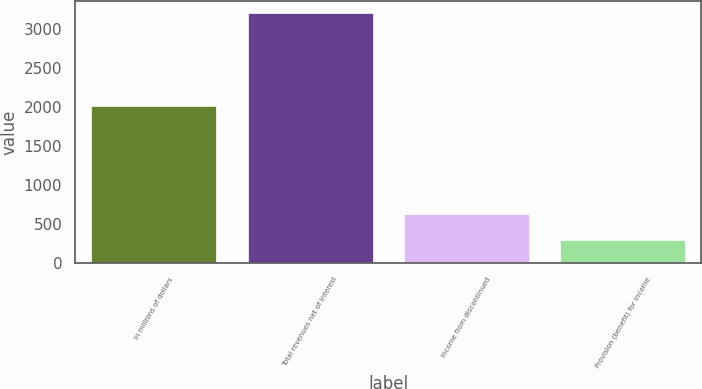<chart> <loc_0><loc_0><loc_500><loc_500><bar_chart><fcel>In millions of dollars<fcel>Total revenues net of interest<fcel>Income from discontinued<fcel>Provision (benefit) for income<nl><fcel>2007<fcel>3203<fcel>628<fcel>297<nl></chart> 